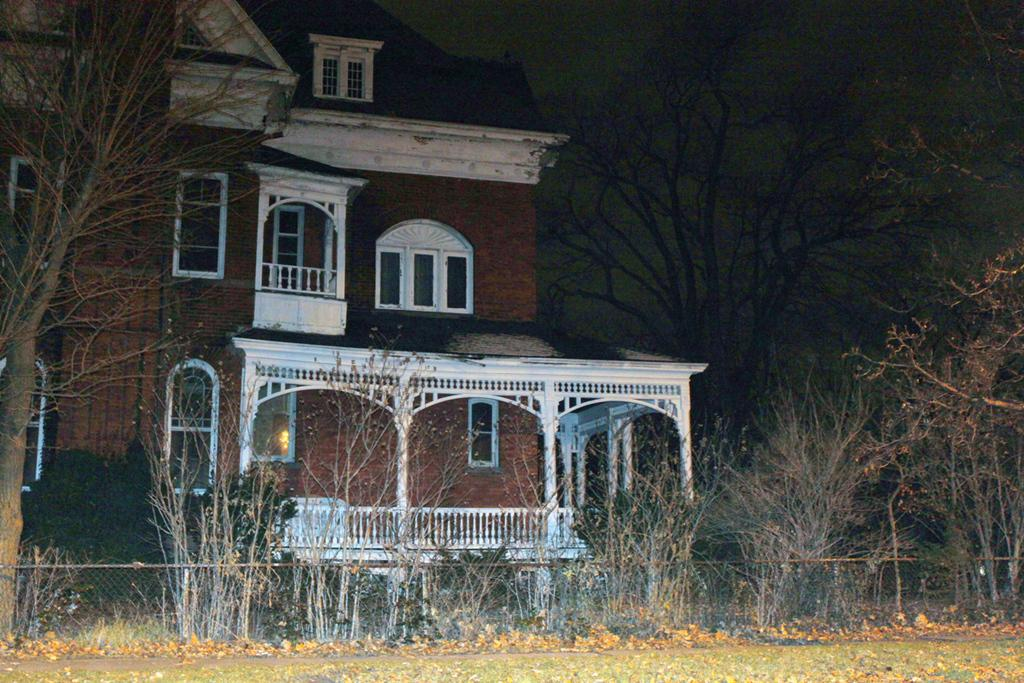What type of structure is present in the image? There is a house in the image. What feature can be seen on the house? The house has windows. What is the color of the house? The house is brown in color. What is located in front of the house? There are many trees in front of the house. What additional detail can be observed in the image? There is a railing in the image. Can you see any blades or caves in the image? No, there are no blades or caves present in the image. Are there any pears visible in the image? No, there are no pears visible in the image. 